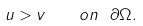<formula> <loc_0><loc_0><loc_500><loc_500>u > v \quad o n \ \partial \Omega .</formula> 